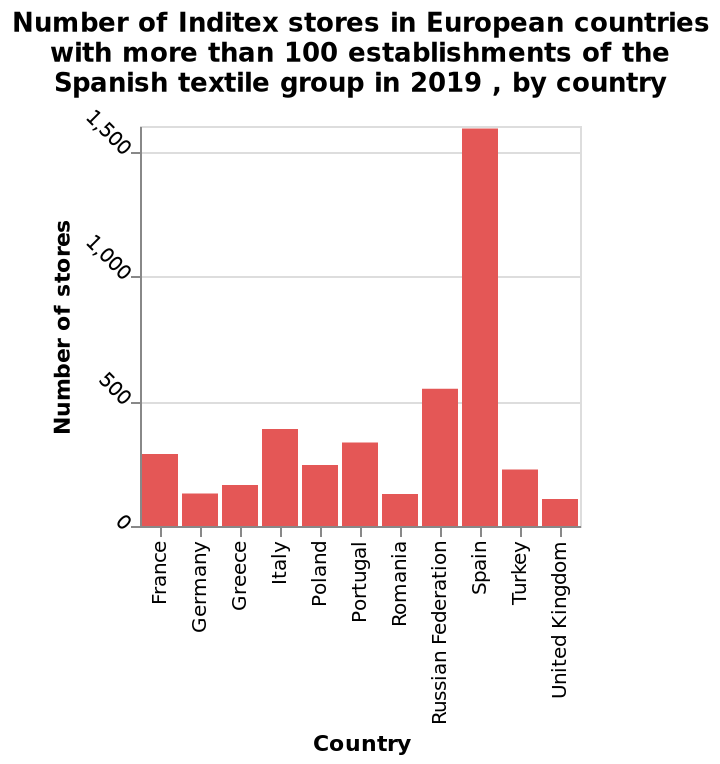<image>
How many stores does Spain have? Spain has over 1500 stores. Offer a thorough analysis of the image. Spain has the most stores with over 1500. In second place is Russian Federation with just over 500. In third place is Italy and the country with the least amount is UK. Which country is in third place in terms of the number of stores?  Italy is in third place. 